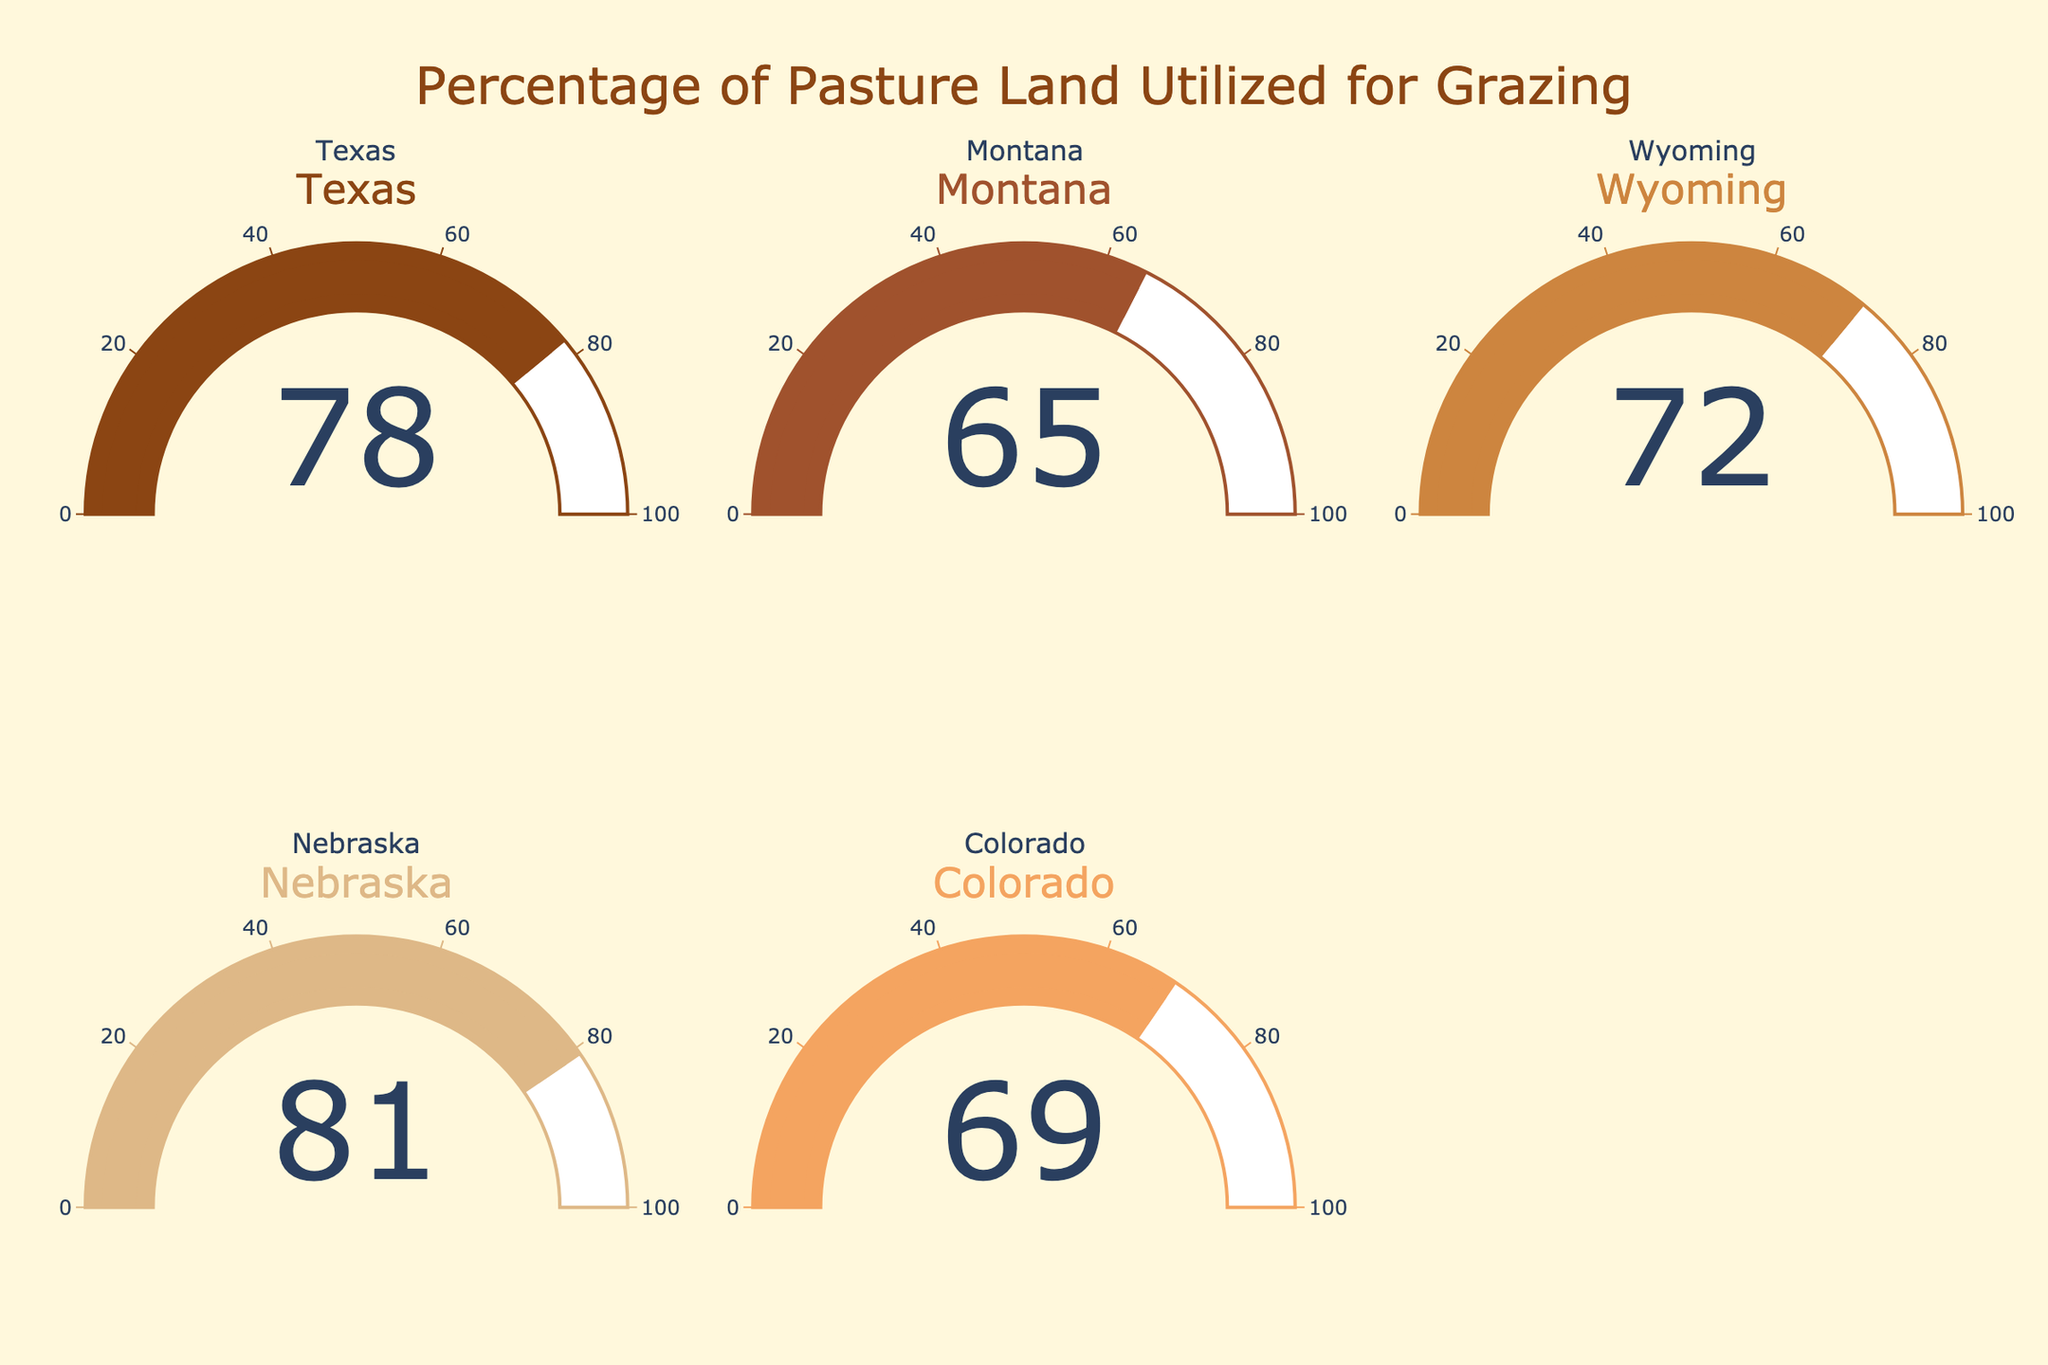What is the title of the gauge chart? The title is prominently displayed at the top center of the chart. It reads "Percentage of Pasture Land Utilized for Grazing".
Answer: Percentage of Pasture Land Utilized for Grazing Which region has the highest percentage of pasture land utilized for grazing? By observing the numbers on each gauge, Nebraska has the highest utilization percentage at 81%.
Answer: Nebraska What is the utilization percentage for Montana? The gauge for Montana shows the utilization percentage directly inside the gauge.
Answer: 65% Compare the utilization percentages for Texas and Colorado. Which one is higher? Looking at the gauges for Texas and Colorado, Texas shows 78% while Colorado shows 69%. Therefore, Texas has a higher utilization percentage.
Answer: Texas What is the difference between the utilization percentages of Nebraska and Wyoming? Nebraska's utilization is 81% and Wyoming's is 72%. Subtract Wyoming's percentage from Nebraska's: 81% - 72% = 9%.
Answer: 9% Calculate the average utilization percentage for all the regions displayed. Sum all percentages: 78 (Texas) + 65 (Montana) + 72 (Wyoming) + 81 (Nebraska) + 69 (Colorado) = 365. Then, divide by the number of regions: 365 / 5 = 73%.
Answer: 73% Rank the regions from highest to lowest utilization percentage. The percentages are: Nebraska (81%), Texas (78%), Wyoming (72%), Colorado (69%), and Montana (65%).
Answer: Nebraska, Texas, Wyoming, Colorado, Montana Which region has the lowest utilization of pasture land for grazing? By examining the lowest number across all gauges, Montana has the lowest utilization at 65%.
Answer: Montana Is the utilization percentage of Wyoming closer to Texas or Colorado? Wyoming's percentage is 72%. The differences are: Texas (78) - Wyoming (72) = 6 and Wyoming (72) - Colorado (69) = 3. Wyoming is closer to Colorado.
Answer: Colorado 